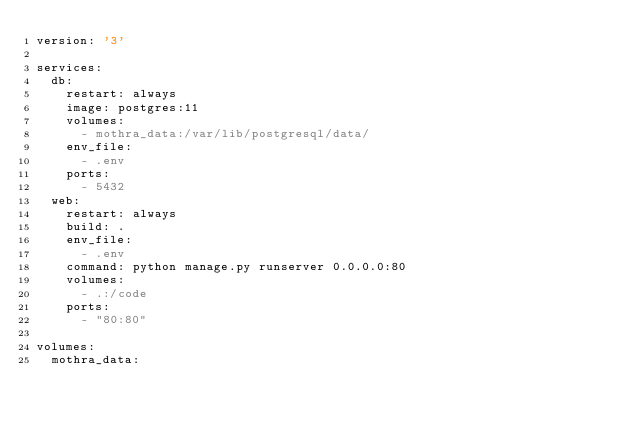<code> <loc_0><loc_0><loc_500><loc_500><_YAML_>version: '3'

services:
  db:
    restart: always
    image: postgres:11
    volumes:
      - mothra_data:/var/lib/postgresql/data/
    env_file:
      - .env
    ports:
      - 5432
  web:
    restart: always
    build: .
    env_file:
      - .env
    command: python manage.py runserver 0.0.0.0:80
    volumes:
      - .:/code
    ports:
      - "80:80"

volumes:
  mothra_data:
</code> 